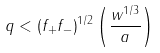<formula> <loc_0><loc_0><loc_500><loc_500>q < \left ( f _ { + } f _ { - } \right ) ^ { 1 / 2 } \left ( \frac { w ^ { 1 / 3 } } { a } \right )</formula> 